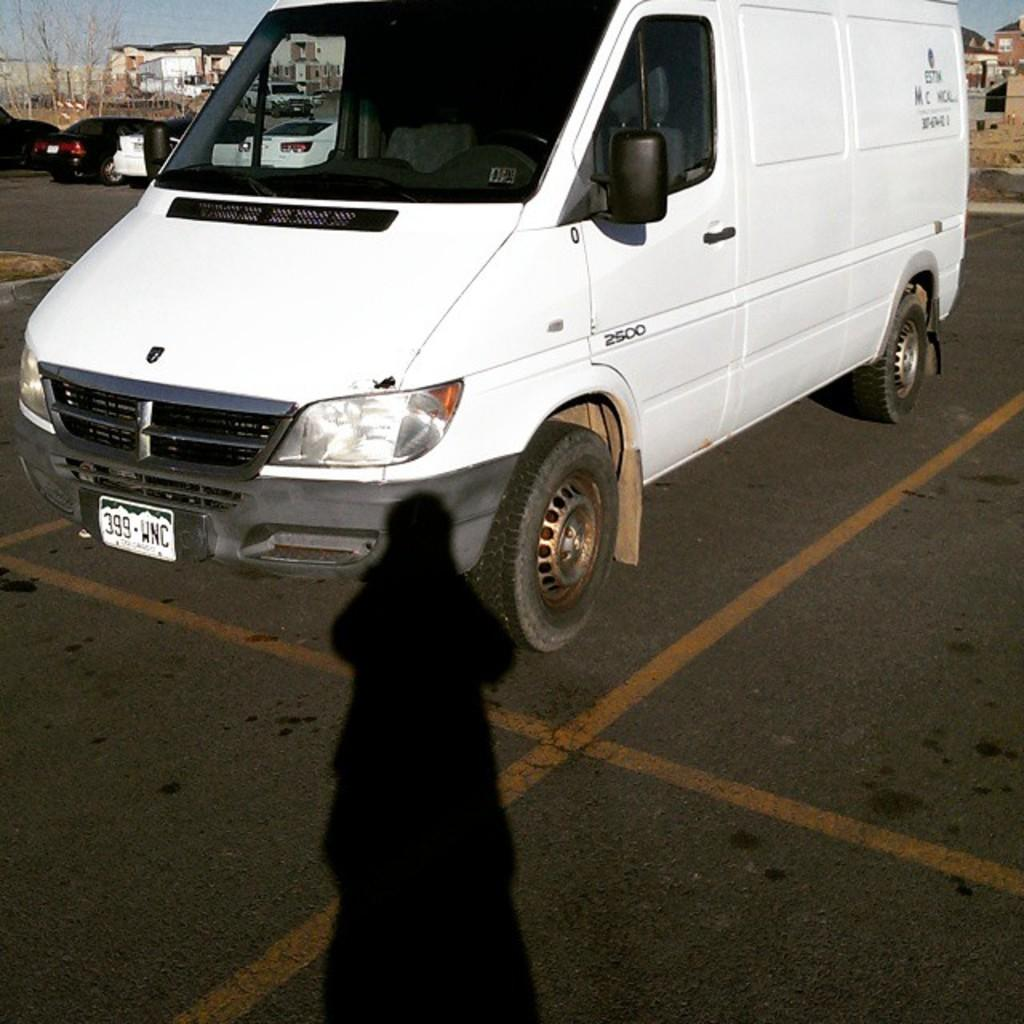<image>
Write a terse but informative summary of the picture. A white van is parked in a parking lot and says 2500 on the driver's door. 